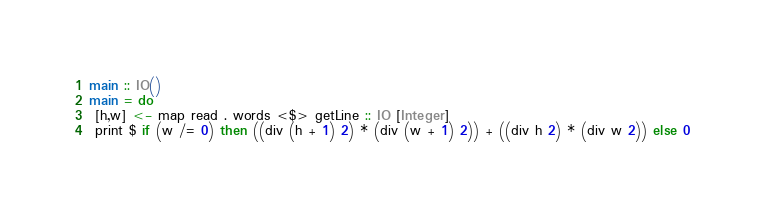Convert code to text. <code><loc_0><loc_0><loc_500><loc_500><_Haskell_>main :: IO()
main = do
 [h,w] <- map read . words <$> getLine :: IO [Integer]
 print $ if (w /= 0) then ((div (h + 1) 2) * (div (w + 1) 2)) + ((div h 2) * (div w 2)) else 0</code> 